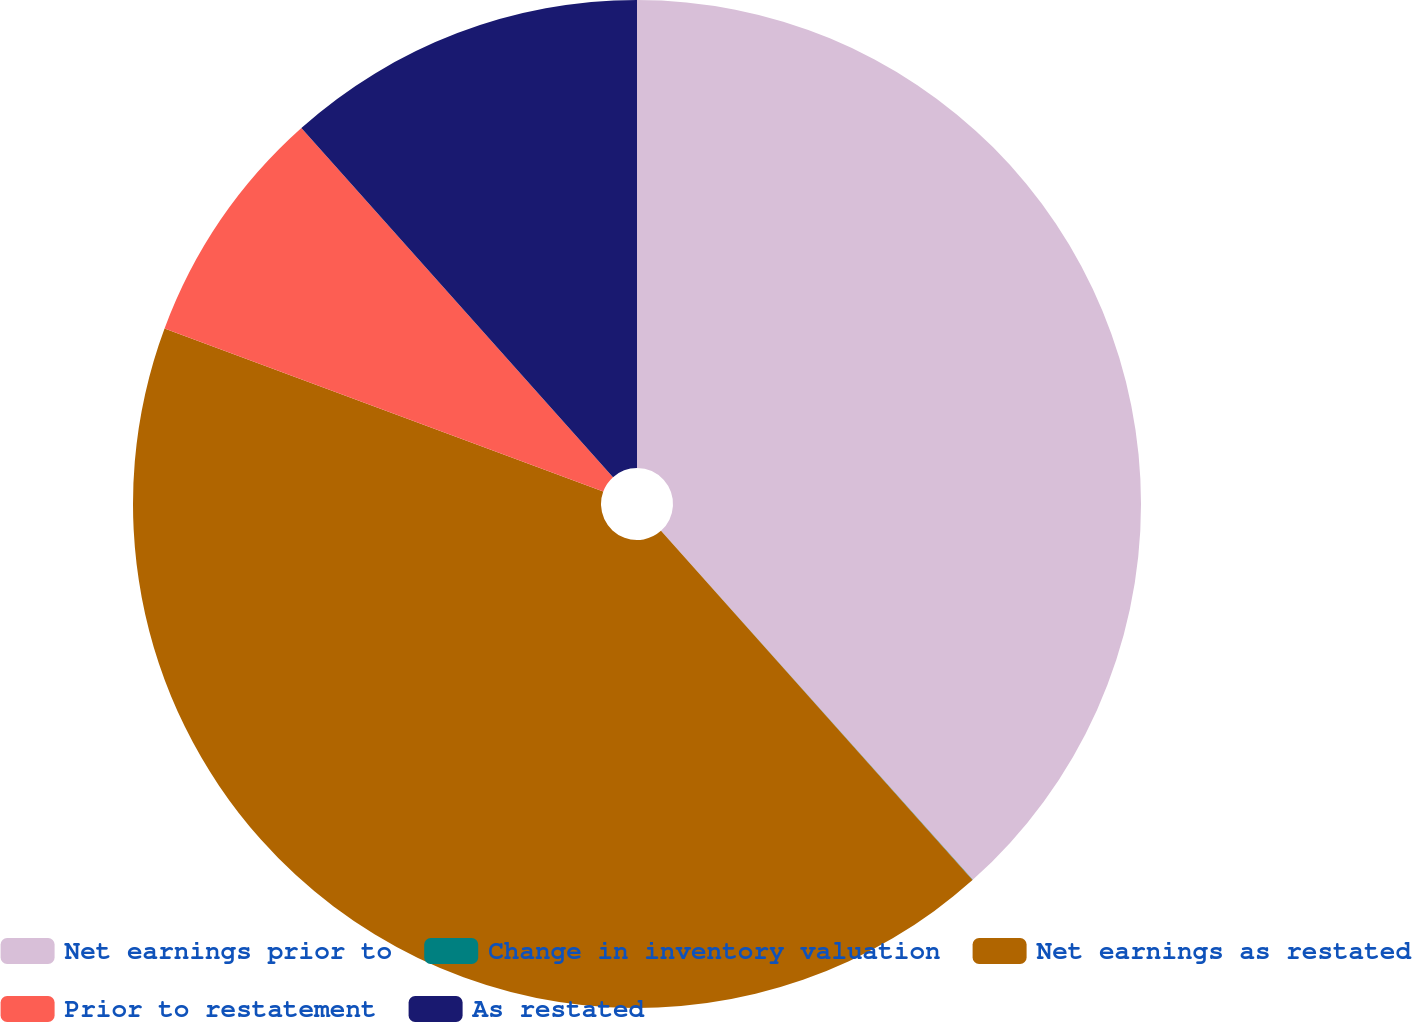Convert chart to OTSL. <chart><loc_0><loc_0><loc_500><loc_500><pie_chart><fcel>Net earnings prior to<fcel>Change in inventory valuation<fcel>Net earnings as restated<fcel>Prior to restatement<fcel>As restated<nl><fcel>38.4%<fcel>0.01%<fcel>42.26%<fcel>7.74%<fcel>11.6%<nl></chart> 